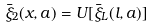<formula> <loc_0><loc_0><loc_500><loc_500>\bar { \xi } _ { 2 } ( x , a ) = U [ \bar { \xi } _ { L } ( l , a ) ]</formula> 